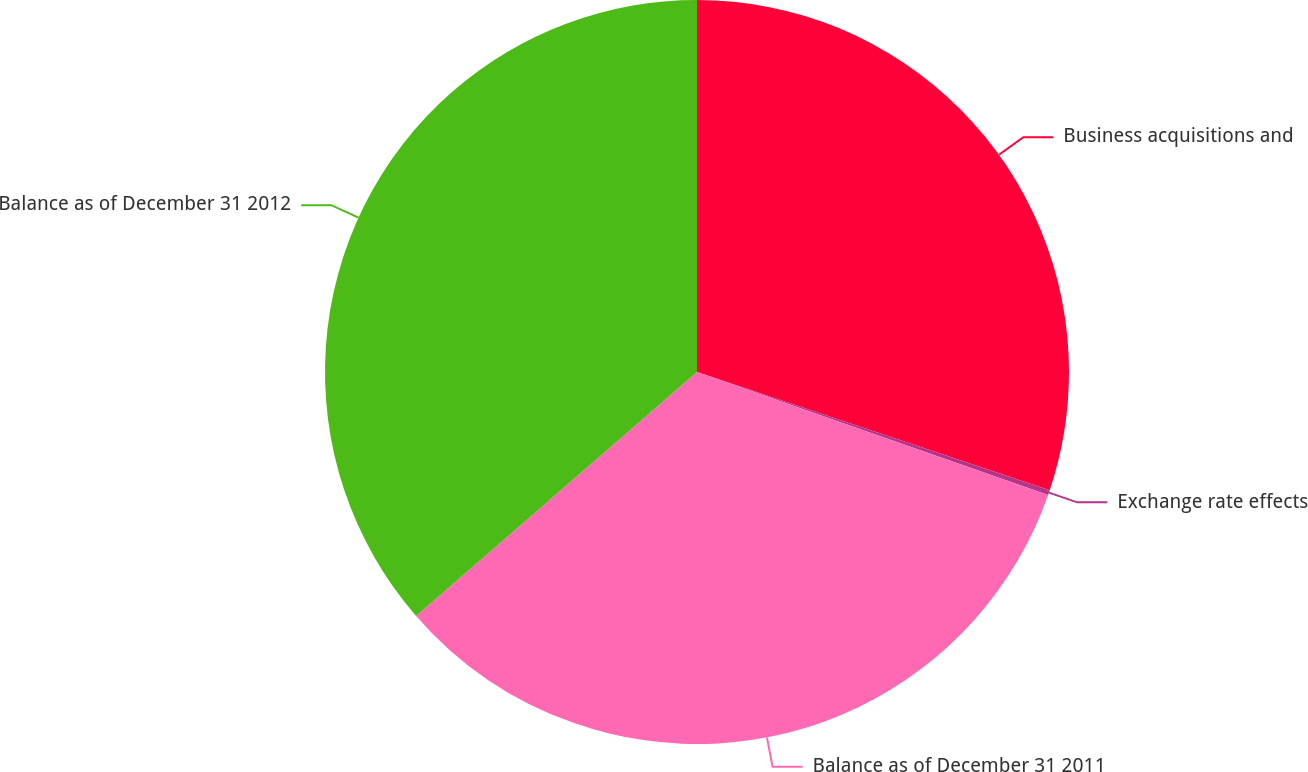<chart> <loc_0><loc_0><loc_500><loc_500><pie_chart><fcel>Business acquisitions and<fcel>Exchange rate effects<fcel>Balance as of December 31 2011<fcel>Balance as of December 31 2012<nl><fcel>30.15%<fcel>0.21%<fcel>33.26%<fcel>36.38%<nl></chart> 